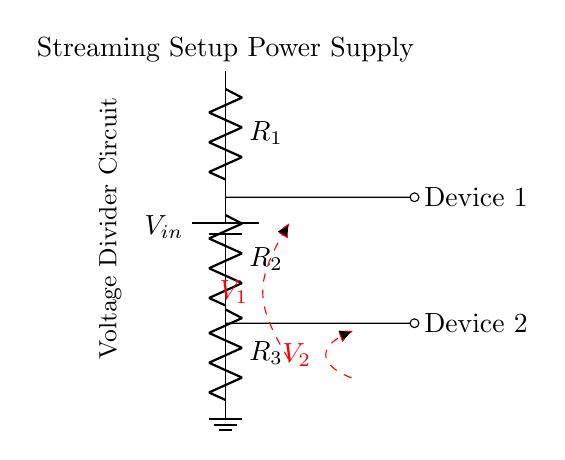What is the input voltage in this circuit? The input voltage is represented as V_in in the circuit diagram, indicating the source voltage supplied to the voltage divider.
Answer: V_in What type of components are R1, R2, and R3? R1, R2, and R3 are resistors as denoted by the letter R in the circuit diagram.
Answer: Resistors What are the voltage outputs for the devices? The voltage across Device 1 (V1) and Device 2 (V2) can be inferred from their positions in the circuit. V1 is at the node between R1 and R2, while V2 is at the node between R2 and R3.
Answer: V1 and V2 Which device is connected to the highest voltage? Device 1 is connected to the junction between R1 and R2, which experiences a higher voltage than Device 2 connected between R2 and R3.
Answer: Device 1 How are the devices powered in the circuit? The devices are powered by the voltage that is dropped across the resistors in a voltage divider setup, which provides different output voltages for each device based on their respective resistor connections.
Answer: Voltage divider What is the configuration type of this circuit? The configuration is a voltage divider circuit used to distribute voltage to multiple outputs, specifically tailored for powering electronic devices in a setup.
Answer: Voltage divider circuit What is the role of the ground in this circuit? The ground serves as a reference point for the circuit, allowing the voltage levels to be defined accurately. It is crucial to provide a common return path for the current.
Answer: Reference point 